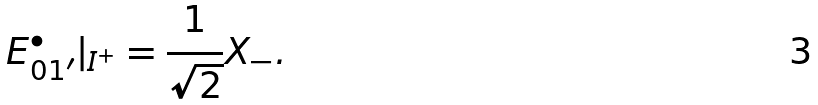<formula> <loc_0><loc_0><loc_500><loc_500>E ^ { \bullet } _ { 0 1 ^ { \prime } } | _ { I ^ { + } } = \frac { 1 } { \sqrt { 2 } } X _ { - } .</formula> 